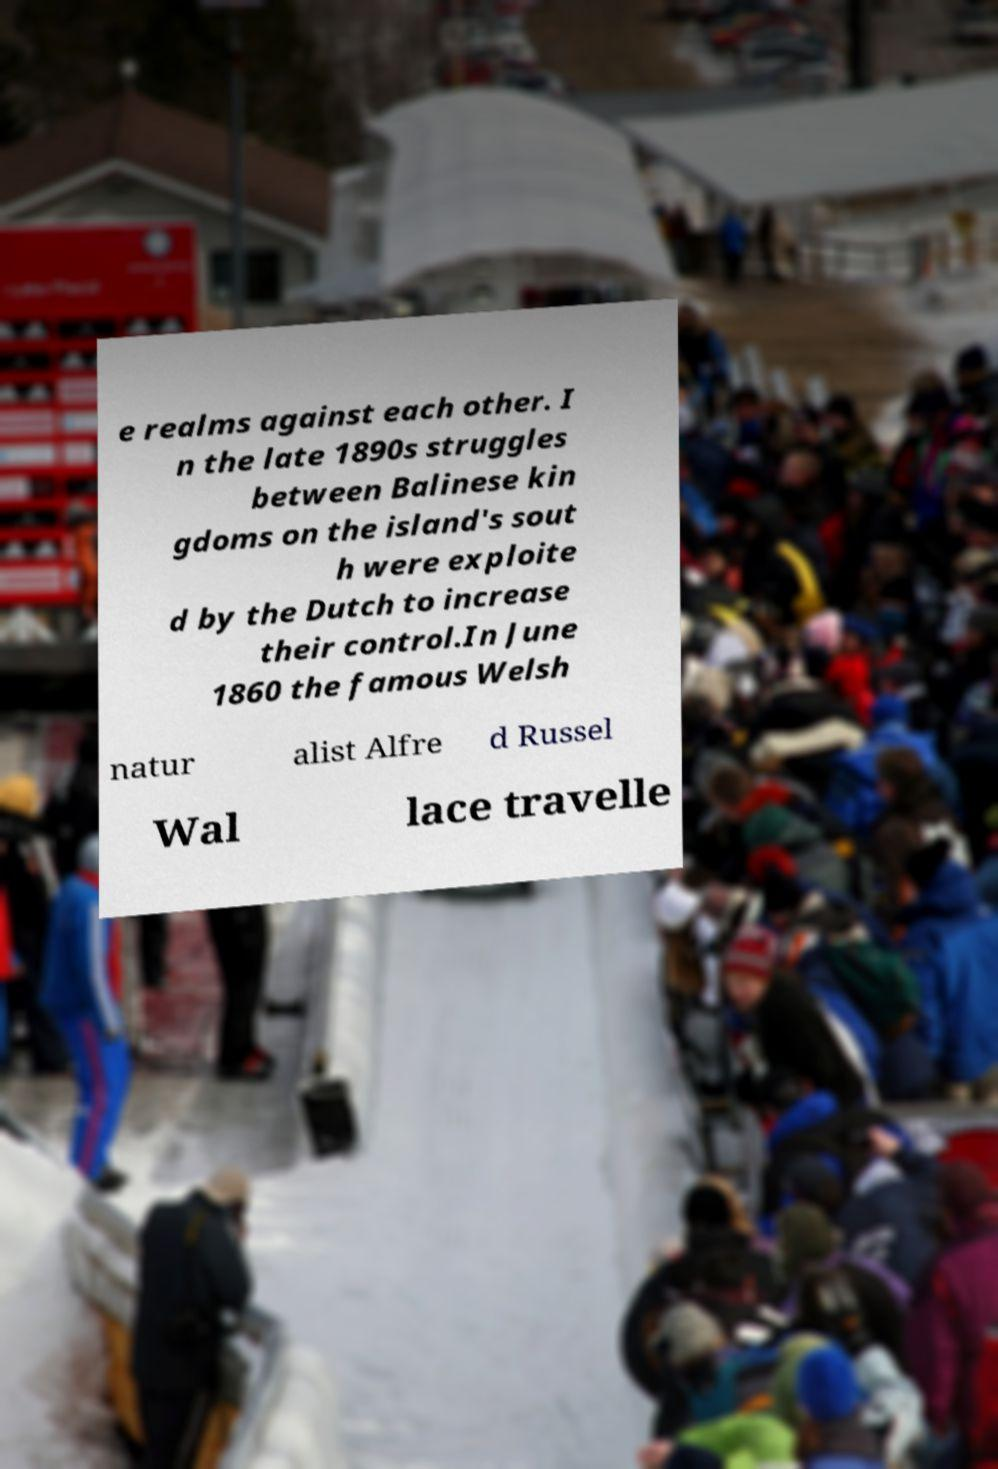I need the written content from this picture converted into text. Can you do that? e realms against each other. I n the late 1890s struggles between Balinese kin gdoms on the island's sout h were exploite d by the Dutch to increase their control.In June 1860 the famous Welsh natur alist Alfre d Russel Wal lace travelle 